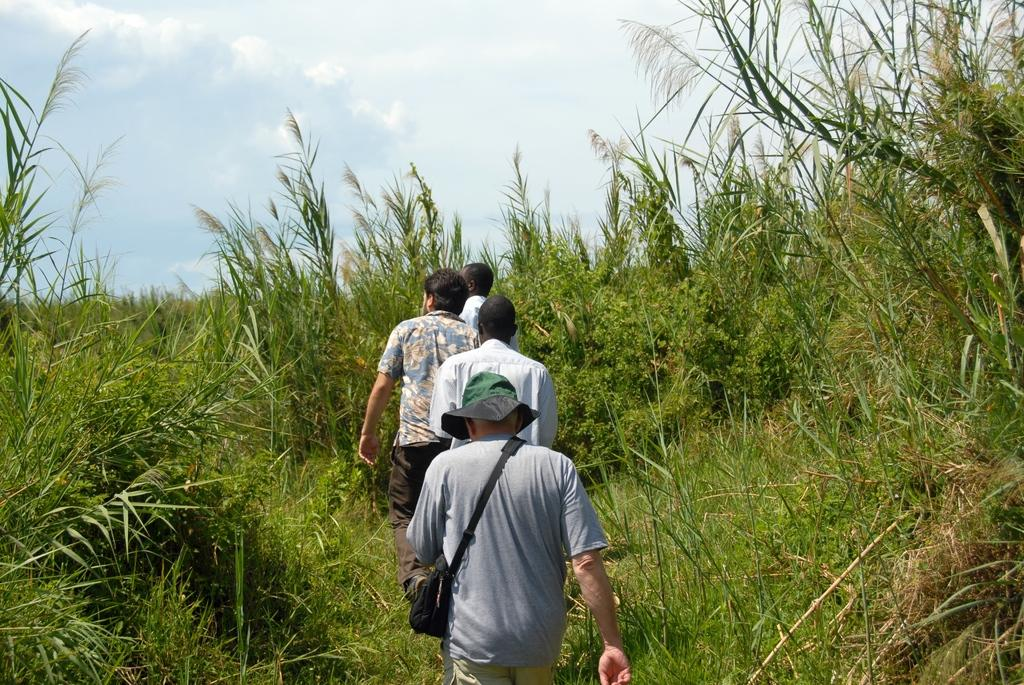What is happening in the image? There is a group of people in the image, and they are walking in a field. Can you describe the attire of the last person in the group? The last person in the group is wearing a bag and a cap. What can be seen in the background of the image? There are trees and plants visible around the people. What type of tin can be seen in the image? There is no tin present in the image. How many eggs are visible in the image? There are no eggs visible in the image. 